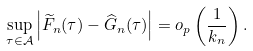Convert formula to latex. <formula><loc_0><loc_0><loc_500><loc_500>\sup _ { \tau \in \mathcal { A } } \left | \widetilde { F } _ { n } ( \tau ) - \widehat { G } _ { n } ( \tau ) \right | = o _ { p } \left ( \frac { 1 } { k _ { n } } \right ) .</formula> 